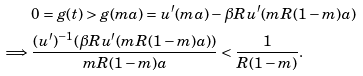Convert formula to latex. <formula><loc_0><loc_0><loc_500><loc_500>& 0 = g ( t ) > g ( m a ) = u ^ { \prime } ( m a ) - \beta R u ^ { \prime } ( m R ( 1 - m ) a ) \\ \implies & \frac { ( u ^ { \prime } ) ^ { - 1 } ( \beta R u ^ { \prime } ( m R ( 1 - m ) a ) ) } { m R ( 1 - m ) a } < \frac { 1 } { R ( 1 - m ) } .</formula> 